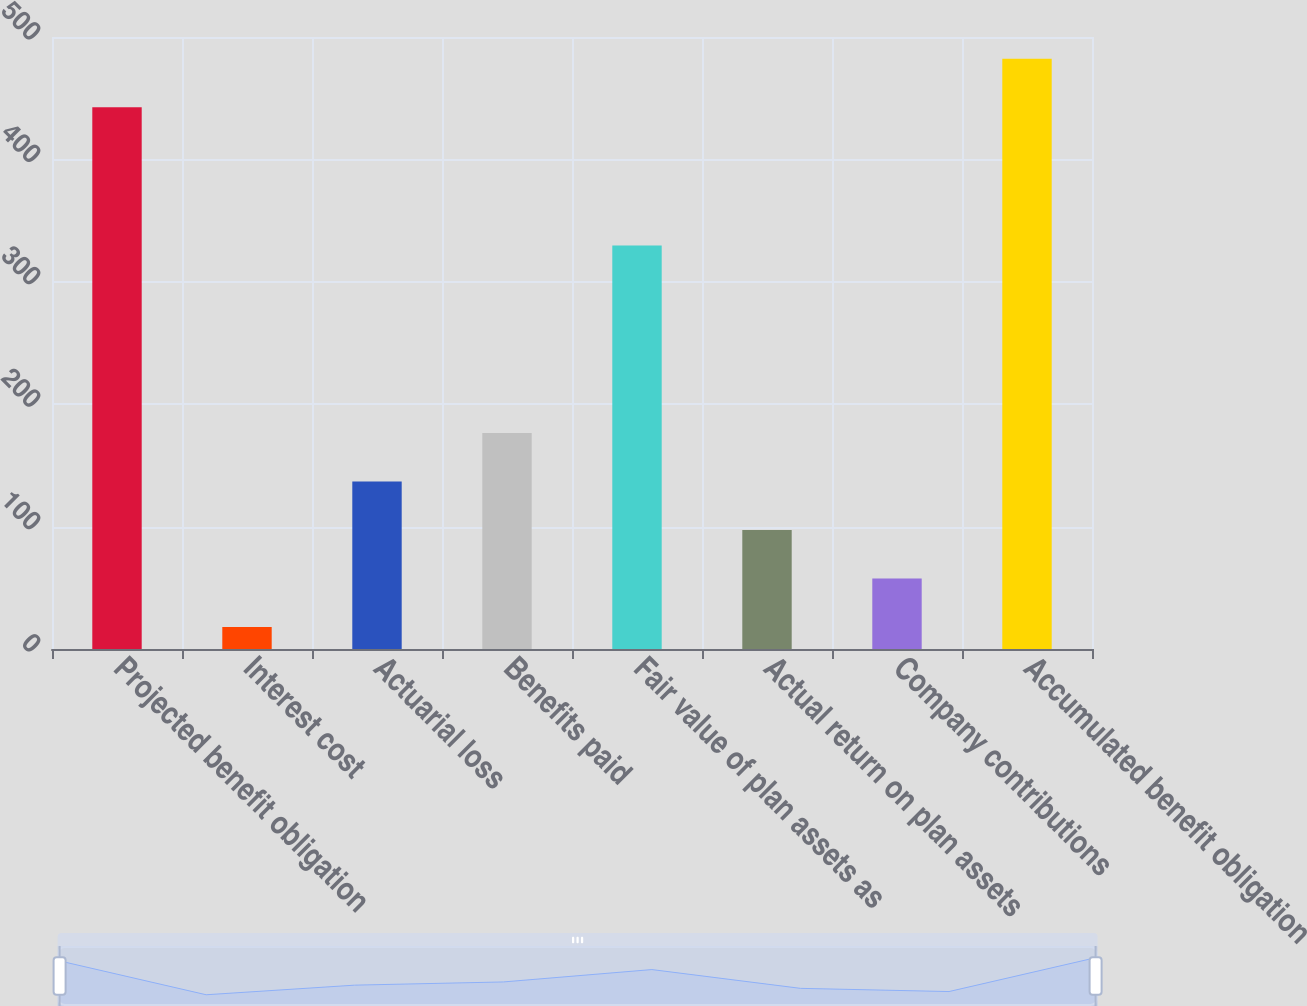Convert chart. <chart><loc_0><loc_0><loc_500><loc_500><bar_chart><fcel>Projected benefit obligation<fcel>Interest cost<fcel>Actuarial loss<fcel>Benefits paid<fcel>Fair value of plan assets as<fcel>Actual return on plan assets<fcel>Company contributions<fcel>Accumulated benefit obligation<nl><fcel>442.55<fcel>17.9<fcel>136.85<fcel>176.5<fcel>329.75<fcel>97.2<fcel>57.55<fcel>482.2<nl></chart> 